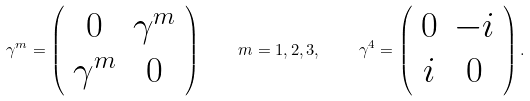Convert formula to latex. <formula><loc_0><loc_0><loc_500><loc_500>\gamma ^ { m } = \left ( \begin{array} { c c } 0 & \gamma ^ { m } \\ \gamma ^ { m } & 0 \end{array} \right ) \quad m = 1 , 2 , 3 , \quad \gamma ^ { 4 } = \left ( \begin{array} { c c } 0 & - i \\ i & 0 \end{array} \right ) .</formula> 